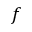Convert formula to latex. <formula><loc_0><loc_0><loc_500><loc_500>f</formula> 